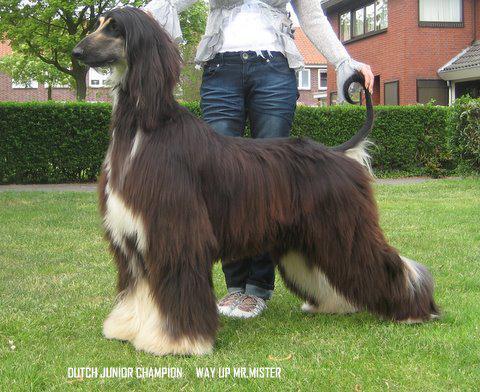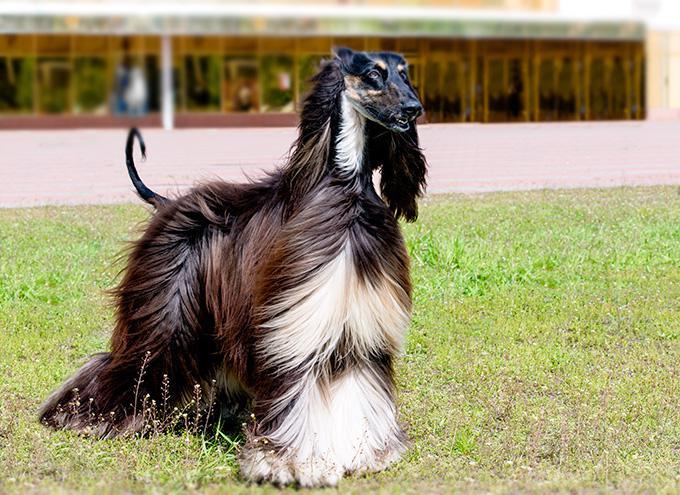The first image is the image on the left, the second image is the image on the right. Assess this claim about the two images: "There are only two dogs, and they are facing in opposite directions of each other.". Correct or not? Answer yes or no. Yes. The first image is the image on the left, the second image is the image on the right. Evaluate the accuracy of this statement regarding the images: "A person in white slacks and a blazer stands directly behind a posed long-haired hound.". Is it true? Answer yes or no. No. The first image is the image on the left, the second image is the image on the right. Evaluate the accuracy of this statement regarding the images: "A person in blue jeans is standing behind a dark afghan hound facing leftward.". Is it true? Answer yes or no. Yes. The first image is the image on the left, the second image is the image on the right. Assess this claim about the two images: "There is a person standing with the dog in the image on the right.". Correct or not? Answer yes or no. No. 